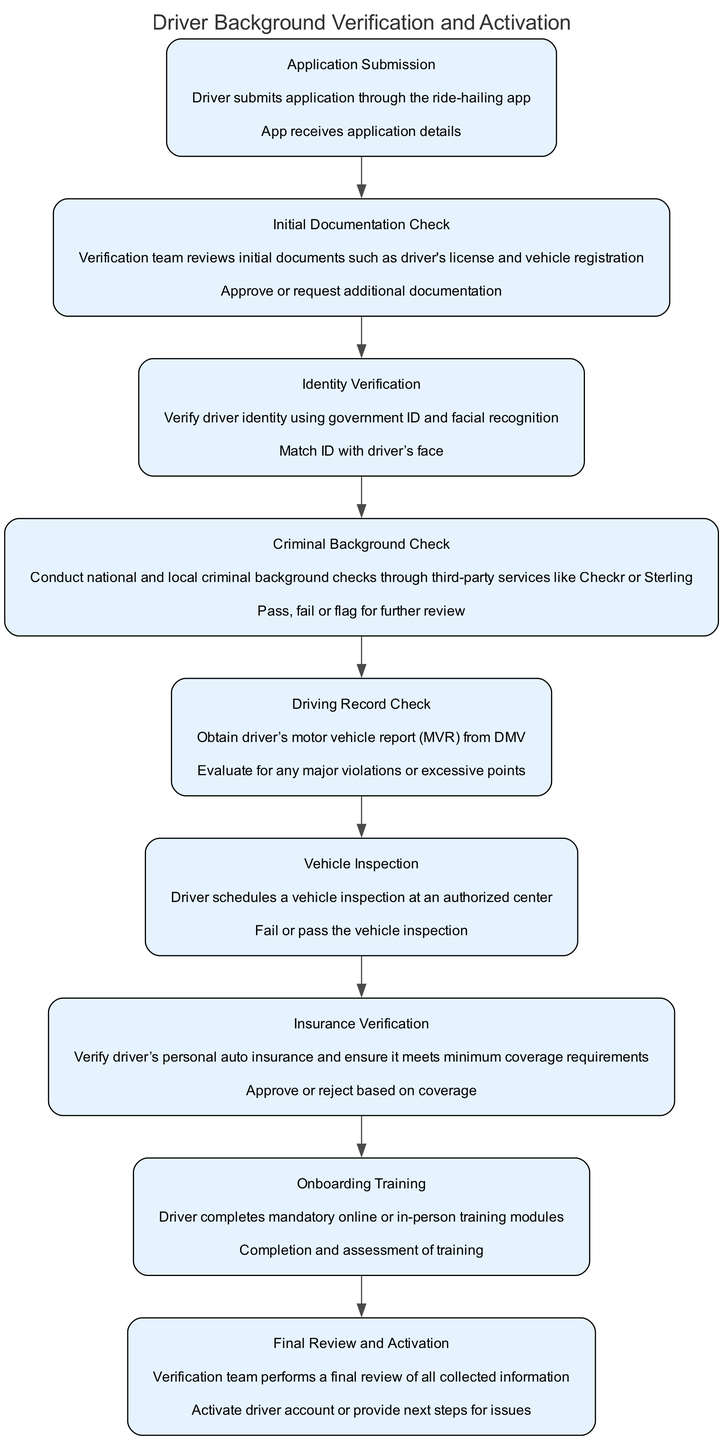What is the first step in the Driver Background Verification process? The first step in the process is "Application Submission," where the driver submits their application through the ride-hailing app.
Answer: Application Submission How many nodes are present in the diagram? The diagram includes a total of nine nodes, each representing a different step in the background verification and activation process.
Answer: Nine What action follows the 'Driving Record Check'? The action that follows the Driving Record Check is 'Vehicle Inspection.' This means after checking the driving record, the driver needs to schedule their vehicle inspection.
Answer: Vehicle Inspection What is the action taken after the 'Criminal Background Check'? After the Criminal Background Check, the action taken is to either pass, fail, or flag the application for further review, as per the findings of the background check.
Answer: Pass, fail or flag for further review Which step requires a vehicle inspection? The step that requires a vehicle inspection is 'Vehicle Inspection,' where the driver schedules and undergoes an inspection at an authorized center.
Answer: Vehicle Inspection What two documents are checked in the 'Initial Documentation Check'? In the Initial Documentation Check, the verification team reviews the driver's license and vehicle registration to verify the documents submitted by the driver.
Answer: Driver's license and vehicle registration What must a driver complete after the 'Insurance Verification' step? After the Insurance Verification step, the driver must complete the 'Onboarding Training' module, which can be online or in-person training formats.
Answer: Onboarding Training What occurs last in the verification process? The final step in the verification process is 'Final Review and Activation,' where the verification team reviews all collected information and activates the driver account or provides next steps.
Answer: Final Review and Activation Which verification step includes a facial recognition check? The verification step that includes a facial recognition check is 'Identity Verification,' where the driver’s identity is matched using their government ID and facial recognition technology.
Answer: Identity Verification 